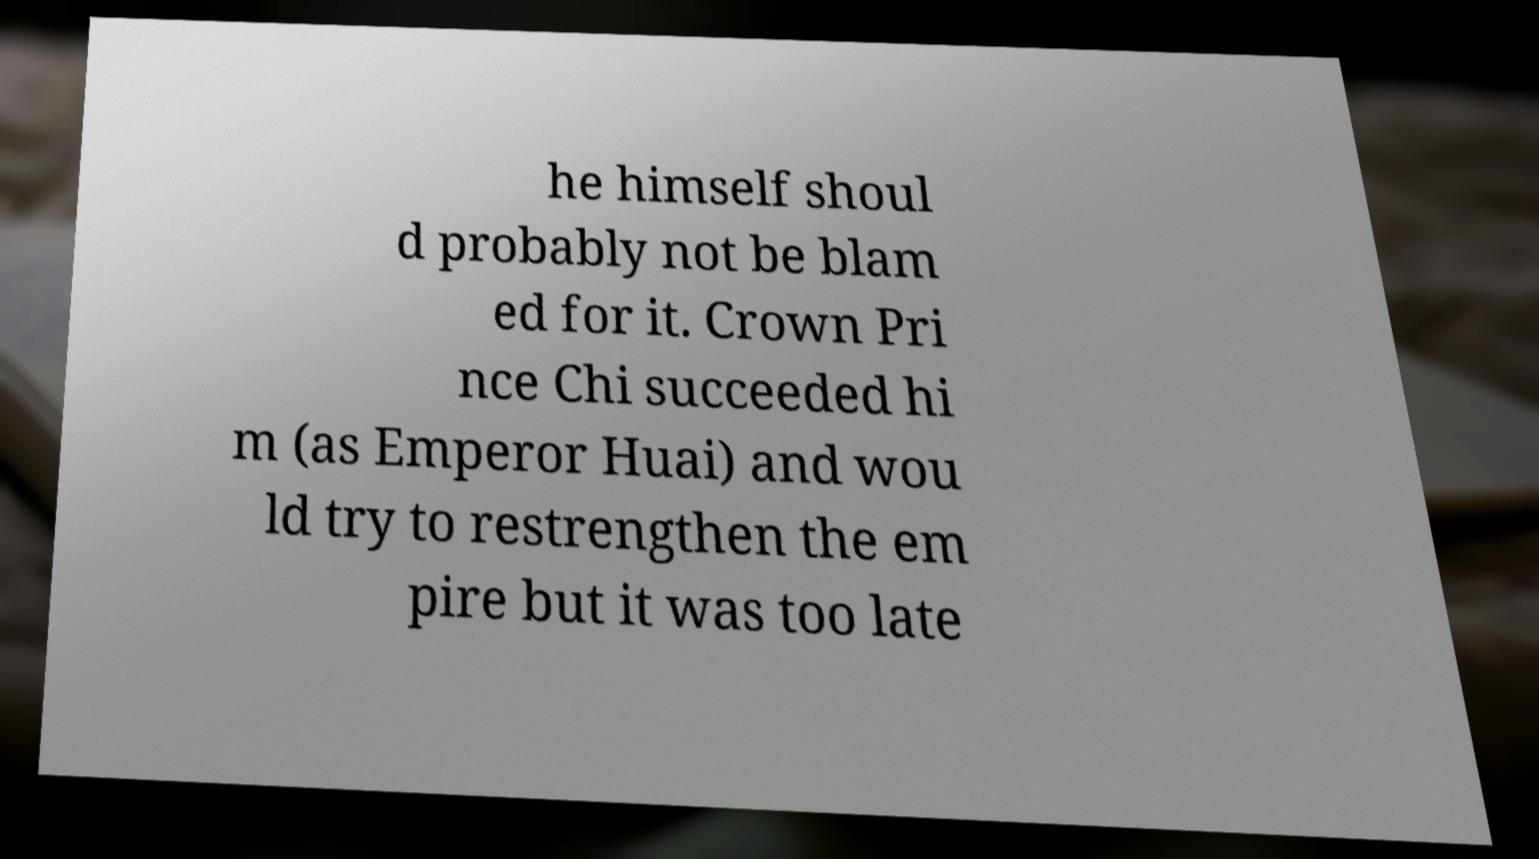Can you accurately transcribe the text from the provided image for me? he himself shoul d probably not be blam ed for it. Crown Pri nce Chi succeeded hi m (as Emperor Huai) and wou ld try to restrengthen the em pire but it was too late 